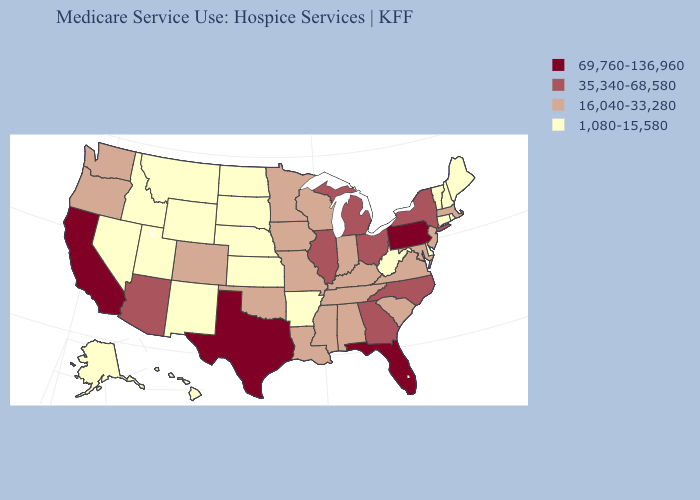What is the highest value in the USA?
Give a very brief answer. 69,760-136,960. Name the states that have a value in the range 1,080-15,580?
Give a very brief answer. Alaska, Arkansas, Connecticut, Delaware, Hawaii, Idaho, Kansas, Maine, Montana, Nebraska, Nevada, New Hampshire, New Mexico, North Dakota, Rhode Island, South Dakota, Utah, Vermont, West Virginia, Wyoming. What is the highest value in the USA?
Be succinct. 69,760-136,960. Which states have the highest value in the USA?
Be succinct. California, Florida, Pennsylvania, Texas. What is the lowest value in the West?
Give a very brief answer. 1,080-15,580. Does Nebraska have the same value as Arizona?
Short answer required. No. What is the value of New Mexico?
Quick response, please. 1,080-15,580. Which states hav the highest value in the Northeast?
Concise answer only. Pennsylvania. Name the states that have a value in the range 35,340-68,580?
Write a very short answer. Arizona, Georgia, Illinois, Michigan, New York, North Carolina, Ohio. What is the lowest value in the USA?
Be succinct. 1,080-15,580. Does Delaware have the lowest value in the South?
Answer briefly. Yes. Among the states that border North Dakota , which have the lowest value?
Short answer required. Montana, South Dakota. Does the map have missing data?
Concise answer only. No. How many symbols are there in the legend?
Write a very short answer. 4. Does Mississippi have the lowest value in the USA?
Short answer required. No. 